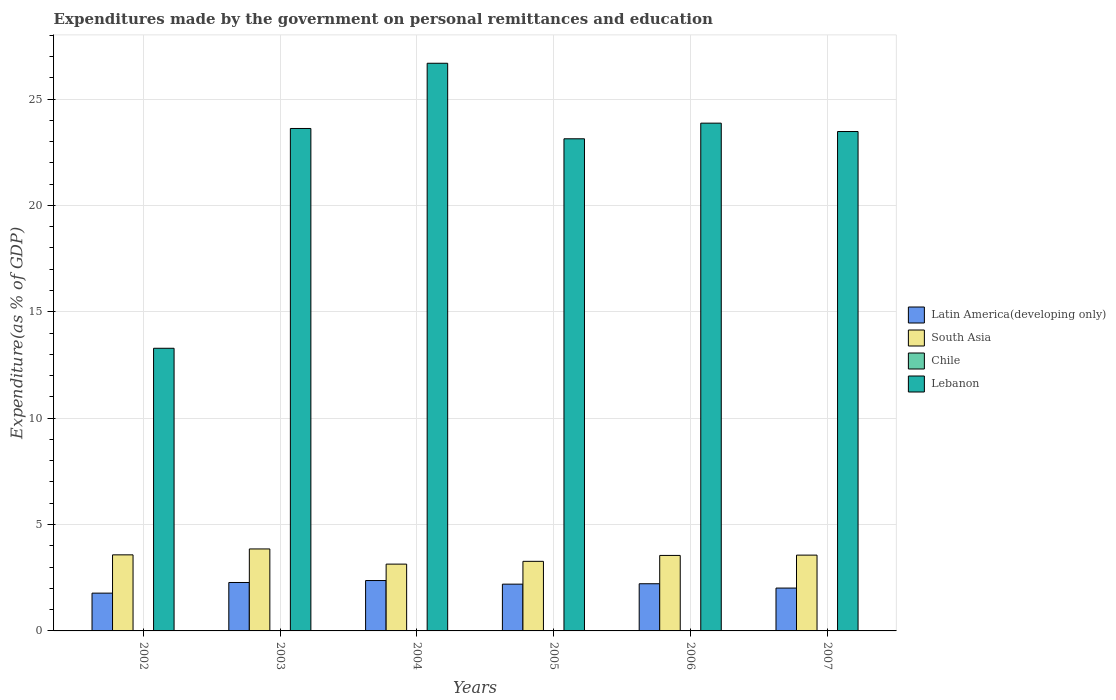How many different coloured bars are there?
Make the answer very short. 4. Are the number of bars on each tick of the X-axis equal?
Ensure brevity in your answer.  Yes. How many bars are there on the 5th tick from the right?
Offer a terse response. 4. In how many cases, is the number of bars for a given year not equal to the number of legend labels?
Provide a succinct answer. 0. What is the expenditures made by the government on personal remittances and education in Lebanon in 2004?
Your answer should be compact. 26.68. Across all years, what is the maximum expenditures made by the government on personal remittances and education in South Asia?
Your answer should be very brief. 3.85. Across all years, what is the minimum expenditures made by the government on personal remittances and education in Latin America(developing only)?
Your answer should be compact. 1.78. What is the total expenditures made by the government on personal remittances and education in Chile in the graph?
Offer a terse response. 0.06. What is the difference between the expenditures made by the government on personal remittances and education in Lebanon in 2003 and that in 2007?
Make the answer very short. 0.14. What is the difference between the expenditures made by the government on personal remittances and education in South Asia in 2006 and the expenditures made by the government on personal remittances and education in Chile in 2002?
Your answer should be very brief. 3.53. What is the average expenditures made by the government on personal remittances and education in Chile per year?
Ensure brevity in your answer.  0.01. In the year 2002, what is the difference between the expenditures made by the government on personal remittances and education in Latin America(developing only) and expenditures made by the government on personal remittances and education in South Asia?
Your answer should be very brief. -1.8. What is the ratio of the expenditures made by the government on personal remittances and education in Latin America(developing only) in 2002 to that in 2007?
Your answer should be compact. 0.88. Is the difference between the expenditures made by the government on personal remittances and education in Latin America(developing only) in 2002 and 2006 greater than the difference between the expenditures made by the government on personal remittances and education in South Asia in 2002 and 2006?
Offer a terse response. No. What is the difference between the highest and the second highest expenditures made by the government on personal remittances and education in Chile?
Make the answer very short. 0. What is the difference between the highest and the lowest expenditures made by the government on personal remittances and education in Lebanon?
Make the answer very short. 13.4. Is the sum of the expenditures made by the government on personal remittances and education in Latin America(developing only) in 2004 and 2005 greater than the maximum expenditures made by the government on personal remittances and education in Lebanon across all years?
Make the answer very short. No. Is it the case that in every year, the sum of the expenditures made by the government on personal remittances and education in South Asia and expenditures made by the government on personal remittances and education in Latin America(developing only) is greater than the sum of expenditures made by the government on personal remittances and education in Chile and expenditures made by the government on personal remittances and education in Lebanon?
Make the answer very short. No. What does the 1st bar from the right in 2005 represents?
Provide a short and direct response. Lebanon. Is it the case that in every year, the sum of the expenditures made by the government on personal remittances and education in South Asia and expenditures made by the government on personal remittances and education in Chile is greater than the expenditures made by the government on personal remittances and education in Latin America(developing only)?
Your response must be concise. Yes. Does the graph contain any zero values?
Ensure brevity in your answer.  No. Does the graph contain grids?
Provide a succinct answer. Yes. Where does the legend appear in the graph?
Your answer should be very brief. Center right. How many legend labels are there?
Provide a short and direct response. 4. How are the legend labels stacked?
Give a very brief answer. Vertical. What is the title of the graph?
Your answer should be compact. Expenditures made by the government on personal remittances and education. Does "Solomon Islands" appear as one of the legend labels in the graph?
Ensure brevity in your answer.  No. What is the label or title of the Y-axis?
Ensure brevity in your answer.  Expenditure(as % of GDP). What is the Expenditure(as % of GDP) of Latin America(developing only) in 2002?
Ensure brevity in your answer.  1.78. What is the Expenditure(as % of GDP) in South Asia in 2002?
Provide a succinct answer. 3.58. What is the Expenditure(as % of GDP) of Chile in 2002?
Offer a terse response. 0.02. What is the Expenditure(as % of GDP) in Lebanon in 2002?
Your response must be concise. 13.29. What is the Expenditure(as % of GDP) in Latin America(developing only) in 2003?
Ensure brevity in your answer.  2.28. What is the Expenditure(as % of GDP) in South Asia in 2003?
Offer a terse response. 3.85. What is the Expenditure(as % of GDP) of Chile in 2003?
Give a very brief answer. 0.02. What is the Expenditure(as % of GDP) in Lebanon in 2003?
Your answer should be compact. 23.62. What is the Expenditure(as % of GDP) of Latin America(developing only) in 2004?
Provide a short and direct response. 2.37. What is the Expenditure(as % of GDP) in South Asia in 2004?
Give a very brief answer. 3.14. What is the Expenditure(as % of GDP) of Chile in 2004?
Give a very brief answer. 0.01. What is the Expenditure(as % of GDP) in Lebanon in 2004?
Your response must be concise. 26.68. What is the Expenditure(as % of GDP) in Latin America(developing only) in 2005?
Give a very brief answer. 2.2. What is the Expenditure(as % of GDP) of South Asia in 2005?
Ensure brevity in your answer.  3.27. What is the Expenditure(as % of GDP) in Chile in 2005?
Make the answer very short. 0.01. What is the Expenditure(as % of GDP) in Lebanon in 2005?
Offer a very short reply. 23.13. What is the Expenditure(as % of GDP) of Latin America(developing only) in 2006?
Keep it short and to the point. 2.22. What is the Expenditure(as % of GDP) of South Asia in 2006?
Offer a very short reply. 3.55. What is the Expenditure(as % of GDP) of Chile in 2006?
Provide a short and direct response. 0. What is the Expenditure(as % of GDP) of Lebanon in 2006?
Your answer should be compact. 23.87. What is the Expenditure(as % of GDP) in Latin America(developing only) in 2007?
Provide a short and direct response. 2.01. What is the Expenditure(as % of GDP) of South Asia in 2007?
Ensure brevity in your answer.  3.56. What is the Expenditure(as % of GDP) in Chile in 2007?
Your answer should be compact. 0. What is the Expenditure(as % of GDP) of Lebanon in 2007?
Keep it short and to the point. 23.47. Across all years, what is the maximum Expenditure(as % of GDP) of Latin America(developing only)?
Provide a succinct answer. 2.37. Across all years, what is the maximum Expenditure(as % of GDP) in South Asia?
Offer a terse response. 3.85. Across all years, what is the maximum Expenditure(as % of GDP) in Chile?
Ensure brevity in your answer.  0.02. Across all years, what is the maximum Expenditure(as % of GDP) of Lebanon?
Ensure brevity in your answer.  26.68. Across all years, what is the minimum Expenditure(as % of GDP) of Latin America(developing only)?
Offer a very short reply. 1.78. Across all years, what is the minimum Expenditure(as % of GDP) in South Asia?
Give a very brief answer. 3.14. Across all years, what is the minimum Expenditure(as % of GDP) of Chile?
Provide a short and direct response. 0. Across all years, what is the minimum Expenditure(as % of GDP) of Lebanon?
Make the answer very short. 13.29. What is the total Expenditure(as % of GDP) in Latin America(developing only) in the graph?
Provide a short and direct response. 12.85. What is the total Expenditure(as % of GDP) in South Asia in the graph?
Provide a succinct answer. 20.95. What is the total Expenditure(as % of GDP) of Chile in the graph?
Give a very brief answer. 0.06. What is the total Expenditure(as % of GDP) of Lebanon in the graph?
Offer a terse response. 134.06. What is the difference between the Expenditure(as % of GDP) of Latin America(developing only) in 2002 and that in 2003?
Offer a very short reply. -0.5. What is the difference between the Expenditure(as % of GDP) of South Asia in 2002 and that in 2003?
Make the answer very short. -0.28. What is the difference between the Expenditure(as % of GDP) of Chile in 2002 and that in 2003?
Provide a succinct answer. 0. What is the difference between the Expenditure(as % of GDP) of Lebanon in 2002 and that in 2003?
Your answer should be compact. -10.33. What is the difference between the Expenditure(as % of GDP) of Latin America(developing only) in 2002 and that in 2004?
Ensure brevity in your answer.  -0.59. What is the difference between the Expenditure(as % of GDP) of South Asia in 2002 and that in 2004?
Your answer should be very brief. 0.44. What is the difference between the Expenditure(as % of GDP) of Chile in 2002 and that in 2004?
Provide a short and direct response. 0.01. What is the difference between the Expenditure(as % of GDP) in Lebanon in 2002 and that in 2004?
Provide a succinct answer. -13.4. What is the difference between the Expenditure(as % of GDP) in Latin America(developing only) in 2002 and that in 2005?
Make the answer very short. -0.42. What is the difference between the Expenditure(as % of GDP) of South Asia in 2002 and that in 2005?
Give a very brief answer. 0.3. What is the difference between the Expenditure(as % of GDP) of Chile in 2002 and that in 2005?
Your answer should be compact. 0.01. What is the difference between the Expenditure(as % of GDP) of Lebanon in 2002 and that in 2005?
Offer a terse response. -9.85. What is the difference between the Expenditure(as % of GDP) in Latin America(developing only) in 2002 and that in 2006?
Offer a very short reply. -0.44. What is the difference between the Expenditure(as % of GDP) in South Asia in 2002 and that in 2006?
Provide a short and direct response. 0.03. What is the difference between the Expenditure(as % of GDP) of Chile in 2002 and that in 2006?
Make the answer very short. 0.02. What is the difference between the Expenditure(as % of GDP) in Lebanon in 2002 and that in 2006?
Provide a short and direct response. -10.58. What is the difference between the Expenditure(as % of GDP) of Latin America(developing only) in 2002 and that in 2007?
Offer a very short reply. -0.24. What is the difference between the Expenditure(as % of GDP) in South Asia in 2002 and that in 2007?
Make the answer very short. 0.01. What is the difference between the Expenditure(as % of GDP) of Chile in 2002 and that in 2007?
Ensure brevity in your answer.  0.02. What is the difference between the Expenditure(as % of GDP) of Lebanon in 2002 and that in 2007?
Ensure brevity in your answer.  -10.19. What is the difference between the Expenditure(as % of GDP) of Latin America(developing only) in 2003 and that in 2004?
Give a very brief answer. -0.09. What is the difference between the Expenditure(as % of GDP) in South Asia in 2003 and that in 2004?
Ensure brevity in your answer.  0.71. What is the difference between the Expenditure(as % of GDP) of Chile in 2003 and that in 2004?
Your response must be concise. 0. What is the difference between the Expenditure(as % of GDP) of Lebanon in 2003 and that in 2004?
Provide a short and direct response. -3.07. What is the difference between the Expenditure(as % of GDP) in Latin America(developing only) in 2003 and that in 2005?
Make the answer very short. 0.08. What is the difference between the Expenditure(as % of GDP) in South Asia in 2003 and that in 2005?
Your response must be concise. 0.58. What is the difference between the Expenditure(as % of GDP) of Chile in 2003 and that in 2005?
Provide a short and direct response. 0. What is the difference between the Expenditure(as % of GDP) in Lebanon in 2003 and that in 2005?
Provide a succinct answer. 0.48. What is the difference between the Expenditure(as % of GDP) in Latin America(developing only) in 2003 and that in 2006?
Ensure brevity in your answer.  0.06. What is the difference between the Expenditure(as % of GDP) of South Asia in 2003 and that in 2006?
Your answer should be very brief. 0.3. What is the difference between the Expenditure(as % of GDP) of Chile in 2003 and that in 2006?
Keep it short and to the point. 0.01. What is the difference between the Expenditure(as % of GDP) of Lebanon in 2003 and that in 2006?
Ensure brevity in your answer.  -0.25. What is the difference between the Expenditure(as % of GDP) of Latin America(developing only) in 2003 and that in 2007?
Your answer should be compact. 0.26. What is the difference between the Expenditure(as % of GDP) of South Asia in 2003 and that in 2007?
Ensure brevity in your answer.  0.29. What is the difference between the Expenditure(as % of GDP) in Chile in 2003 and that in 2007?
Your answer should be very brief. 0.01. What is the difference between the Expenditure(as % of GDP) in Lebanon in 2003 and that in 2007?
Give a very brief answer. 0.14. What is the difference between the Expenditure(as % of GDP) in Latin America(developing only) in 2004 and that in 2005?
Keep it short and to the point. 0.17. What is the difference between the Expenditure(as % of GDP) in South Asia in 2004 and that in 2005?
Keep it short and to the point. -0.13. What is the difference between the Expenditure(as % of GDP) of Chile in 2004 and that in 2005?
Your response must be concise. 0. What is the difference between the Expenditure(as % of GDP) in Lebanon in 2004 and that in 2005?
Your answer should be very brief. 3.55. What is the difference between the Expenditure(as % of GDP) of Latin America(developing only) in 2004 and that in 2006?
Provide a succinct answer. 0.15. What is the difference between the Expenditure(as % of GDP) in South Asia in 2004 and that in 2006?
Provide a succinct answer. -0.41. What is the difference between the Expenditure(as % of GDP) in Chile in 2004 and that in 2006?
Offer a very short reply. 0.01. What is the difference between the Expenditure(as % of GDP) in Lebanon in 2004 and that in 2006?
Make the answer very short. 2.82. What is the difference between the Expenditure(as % of GDP) in Latin America(developing only) in 2004 and that in 2007?
Offer a very short reply. 0.35. What is the difference between the Expenditure(as % of GDP) in South Asia in 2004 and that in 2007?
Keep it short and to the point. -0.42. What is the difference between the Expenditure(as % of GDP) in Chile in 2004 and that in 2007?
Provide a short and direct response. 0.01. What is the difference between the Expenditure(as % of GDP) of Lebanon in 2004 and that in 2007?
Provide a succinct answer. 3.21. What is the difference between the Expenditure(as % of GDP) in Latin America(developing only) in 2005 and that in 2006?
Offer a terse response. -0.02. What is the difference between the Expenditure(as % of GDP) of South Asia in 2005 and that in 2006?
Give a very brief answer. -0.28. What is the difference between the Expenditure(as % of GDP) of Chile in 2005 and that in 2006?
Give a very brief answer. 0.01. What is the difference between the Expenditure(as % of GDP) of Lebanon in 2005 and that in 2006?
Provide a short and direct response. -0.74. What is the difference between the Expenditure(as % of GDP) in Latin America(developing only) in 2005 and that in 2007?
Provide a succinct answer. 0.18. What is the difference between the Expenditure(as % of GDP) in South Asia in 2005 and that in 2007?
Your answer should be compact. -0.29. What is the difference between the Expenditure(as % of GDP) of Chile in 2005 and that in 2007?
Provide a succinct answer. 0.01. What is the difference between the Expenditure(as % of GDP) of Lebanon in 2005 and that in 2007?
Offer a very short reply. -0.34. What is the difference between the Expenditure(as % of GDP) in Latin America(developing only) in 2006 and that in 2007?
Offer a terse response. 0.2. What is the difference between the Expenditure(as % of GDP) in South Asia in 2006 and that in 2007?
Your answer should be very brief. -0.01. What is the difference between the Expenditure(as % of GDP) in Chile in 2006 and that in 2007?
Ensure brevity in your answer.  0. What is the difference between the Expenditure(as % of GDP) of Lebanon in 2006 and that in 2007?
Offer a very short reply. 0.39. What is the difference between the Expenditure(as % of GDP) of Latin America(developing only) in 2002 and the Expenditure(as % of GDP) of South Asia in 2003?
Keep it short and to the point. -2.08. What is the difference between the Expenditure(as % of GDP) of Latin America(developing only) in 2002 and the Expenditure(as % of GDP) of Chile in 2003?
Give a very brief answer. 1.76. What is the difference between the Expenditure(as % of GDP) of Latin America(developing only) in 2002 and the Expenditure(as % of GDP) of Lebanon in 2003?
Keep it short and to the point. -21.84. What is the difference between the Expenditure(as % of GDP) of South Asia in 2002 and the Expenditure(as % of GDP) of Chile in 2003?
Offer a very short reply. 3.56. What is the difference between the Expenditure(as % of GDP) in South Asia in 2002 and the Expenditure(as % of GDP) in Lebanon in 2003?
Make the answer very short. -20.04. What is the difference between the Expenditure(as % of GDP) of Chile in 2002 and the Expenditure(as % of GDP) of Lebanon in 2003?
Offer a very short reply. -23.6. What is the difference between the Expenditure(as % of GDP) in Latin America(developing only) in 2002 and the Expenditure(as % of GDP) in South Asia in 2004?
Your response must be concise. -1.36. What is the difference between the Expenditure(as % of GDP) in Latin America(developing only) in 2002 and the Expenditure(as % of GDP) in Chile in 2004?
Give a very brief answer. 1.76. What is the difference between the Expenditure(as % of GDP) of Latin America(developing only) in 2002 and the Expenditure(as % of GDP) of Lebanon in 2004?
Offer a terse response. -24.91. What is the difference between the Expenditure(as % of GDP) of South Asia in 2002 and the Expenditure(as % of GDP) of Chile in 2004?
Your response must be concise. 3.56. What is the difference between the Expenditure(as % of GDP) of South Asia in 2002 and the Expenditure(as % of GDP) of Lebanon in 2004?
Make the answer very short. -23.11. What is the difference between the Expenditure(as % of GDP) of Chile in 2002 and the Expenditure(as % of GDP) of Lebanon in 2004?
Provide a short and direct response. -26.67. What is the difference between the Expenditure(as % of GDP) in Latin America(developing only) in 2002 and the Expenditure(as % of GDP) in South Asia in 2005?
Provide a succinct answer. -1.49. What is the difference between the Expenditure(as % of GDP) of Latin America(developing only) in 2002 and the Expenditure(as % of GDP) of Chile in 2005?
Your answer should be compact. 1.77. What is the difference between the Expenditure(as % of GDP) of Latin America(developing only) in 2002 and the Expenditure(as % of GDP) of Lebanon in 2005?
Provide a short and direct response. -21.36. What is the difference between the Expenditure(as % of GDP) in South Asia in 2002 and the Expenditure(as % of GDP) in Chile in 2005?
Provide a short and direct response. 3.57. What is the difference between the Expenditure(as % of GDP) in South Asia in 2002 and the Expenditure(as % of GDP) in Lebanon in 2005?
Provide a short and direct response. -19.56. What is the difference between the Expenditure(as % of GDP) in Chile in 2002 and the Expenditure(as % of GDP) in Lebanon in 2005?
Ensure brevity in your answer.  -23.11. What is the difference between the Expenditure(as % of GDP) of Latin America(developing only) in 2002 and the Expenditure(as % of GDP) of South Asia in 2006?
Provide a short and direct response. -1.77. What is the difference between the Expenditure(as % of GDP) of Latin America(developing only) in 2002 and the Expenditure(as % of GDP) of Chile in 2006?
Offer a very short reply. 1.77. What is the difference between the Expenditure(as % of GDP) of Latin America(developing only) in 2002 and the Expenditure(as % of GDP) of Lebanon in 2006?
Your answer should be very brief. -22.09. What is the difference between the Expenditure(as % of GDP) in South Asia in 2002 and the Expenditure(as % of GDP) in Chile in 2006?
Keep it short and to the point. 3.57. What is the difference between the Expenditure(as % of GDP) of South Asia in 2002 and the Expenditure(as % of GDP) of Lebanon in 2006?
Ensure brevity in your answer.  -20.29. What is the difference between the Expenditure(as % of GDP) in Chile in 2002 and the Expenditure(as % of GDP) in Lebanon in 2006?
Your response must be concise. -23.85. What is the difference between the Expenditure(as % of GDP) of Latin America(developing only) in 2002 and the Expenditure(as % of GDP) of South Asia in 2007?
Offer a terse response. -1.79. What is the difference between the Expenditure(as % of GDP) in Latin America(developing only) in 2002 and the Expenditure(as % of GDP) in Chile in 2007?
Provide a succinct answer. 1.77. What is the difference between the Expenditure(as % of GDP) of Latin America(developing only) in 2002 and the Expenditure(as % of GDP) of Lebanon in 2007?
Your response must be concise. -21.7. What is the difference between the Expenditure(as % of GDP) in South Asia in 2002 and the Expenditure(as % of GDP) in Chile in 2007?
Your response must be concise. 3.57. What is the difference between the Expenditure(as % of GDP) in South Asia in 2002 and the Expenditure(as % of GDP) in Lebanon in 2007?
Make the answer very short. -19.9. What is the difference between the Expenditure(as % of GDP) in Chile in 2002 and the Expenditure(as % of GDP) in Lebanon in 2007?
Provide a succinct answer. -23.46. What is the difference between the Expenditure(as % of GDP) in Latin America(developing only) in 2003 and the Expenditure(as % of GDP) in South Asia in 2004?
Keep it short and to the point. -0.86. What is the difference between the Expenditure(as % of GDP) of Latin America(developing only) in 2003 and the Expenditure(as % of GDP) of Chile in 2004?
Provide a short and direct response. 2.27. What is the difference between the Expenditure(as % of GDP) in Latin America(developing only) in 2003 and the Expenditure(as % of GDP) in Lebanon in 2004?
Offer a very short reply. -24.41. What is the difference between the Expenditure(as % of GDP) of South Asia in 2003 and the Expenditure(as % of GDP) of Chile in 2004?
Ensure brevity in your answer.  3.84. What is the difference between the Expenditure(as % of GDP) of South Asia in 2003 and the Expenditure(as % of GDP) of Lebanon in 2004?
Give a very brief answer. -22.83. What is the difference between the Expenditure(as % of GDP) of Chile in 2003 and the Expenditure(as % of GDP) of Lebanon in 2004?
Make the answer very short. -26.67. What is the difference between the Expenditure(as % of GDP) of Latin America(developing only) in 2003 and the Expenditure(as % of GDP) of South Asia in 2005?
Offer a very short reply. -0.99. What is the difference between the Expenditure(as % of GDP) in Latin America(developing only) in 2003 and the Expenditure(as % of GDP) in Chile in 2005?
Your answer should be very brief. 2.27. What is the difference between the Expenditure(as % of GDP) in Latin America(developing only) in 2003 and the Expenditure(as % of GDP) in Lebanon in 2005?
Your answer should be compact. -20.86. What is the difference between the Expenditure(as % of GDP) in South Asia in 2003 and the Expenditure(as % of GDP) in Chile in 2005?
Your response must be concise. 3.84. What is the difference between the Expenditure(as % of GDP) of South Asia in 2003 and the Expenditure(as % of GDP) of Lebanon in 2005?
Your answer should be very brief. -19.28. What is the difference between the Expenditure(as % of GDP) of Chile in 2003 and the Expenditure(as % of GDP) of Lebanon in 2005?
Your answer should be very brief. -23.12. What is the difference between the Expenditure(as % of GDP) of Latin America(developing only) in 2003 and the Expenditure(as % of GDP) of South Asia in 2006?
Offer a very short reply. -1.27. What is the difference between the Expenditure(as % of GDP) of Latin America(developing only) in 2003 and the Expenditure(as % of GDP) of Chile in 2006?
Your answer should be very brief. 2.27. What is the difference between the Expenditure(as % of GDP) in Latin America(developing only) in 2003 and the Expenditure(as % of GDP) in Lebanon in 2006?
Keep it short and to the point. -21.59. What is the difference between the Expenditure(as % of GDP) of South Asia in 2003 and the Expenditure(as % of GDP) of Chile in 2006?
Provide a short and direct response. 3.85. What is the difference between the Expenditure(as % of GDP) of South Asia in 2003 and the Expenditure(as % of GDP) of Lebanon in 2006?
Ensure brevity in your answer.  -20.01. What is the difference between the Expenditure(as % of GDP) of Chile in 2003 and the Expenditure(as % of GDP) of Lebanon in 2006?
Your response must be concise. -23.85. What is the difference between the Expenditure(as % of GDP) of Latin America(developing only) in 2003 and the Expenditure(as % of GDP) of South Asia in 2007?
Keep it short and to the point. -1.29. What is the difference between the Expenditure(as % of GDP) in Latin America(developing only) in 2003 and the Expenditure(as % of GDP) in Chile in 2007?
Your answer should be compact. 2.27. What is the difference between the Expenditure(as % of GDP) of Latin America(developing only) in 2003 and the Expenditure(as % of GDP) of Lebanon in 2007?
Ensure brevity in your answer.  -21.2. What is the difference between the Expenditure(as % of GDP) of South Asia in 2003 and the Expenditure(as % of GDP) of Chile in 2007?
Offer a very short reply. 3.85. What is the difference between the Expenditure(as % of GDP) in South Asia in 2003 and the Expenditure(as % of GDP) in Lebanon in 2007?
Ensure brevity in your answer.  -19.62. What is the difference between the Expenditure(as % of GDP) in Chile in 2003 and the Expenditure(as % of GDP) in Lebanon in 2007?
Your answer should be very brief. -23.46. What is the difference between the Expenditure(as % of GDP) of Latin America(developing only) in 2004 and the Expenditure(as % of GDP) of South Asia in 2005?
Your response must be concise. -0.9. What is the difference between the Expenditure(as % of GDP) of Latin America(developing only) in 2004 and the Expenditure(as % of GDP) of Chile in 2005?
Your answer should be very brief. 2.36. What is the difference between the Expenditure(as % of GDP) in Latin America(developing only) in 2004 and the Expenditure(as % of GDP) in Lebanon in 2005?
Provide a succinct answer. -20.76. What is the difference between the Expenditure(as % of GDP) of South Asia in 2004 and the Expenditure(as % of GDP) of Chile in 2005?
Provide a short and direct response. 3.13. What is the difference between the Expenditure(as % of GDP) in South Asia in 2004 and the Expenditure(as % of GDP) in Lebanon in 2005?
Provide a short and direct response. -19.99. What is the difference between the Expenditure(as % of GDP) of Chile in 2004 and the Expenditure(as % of GDP) of Lebanon in 2005?
Your response must be concise. -23.12. What is the difference between the Expenditure(as % of GDP) in Latin America(developing only) in 2004 and the Expenditure(as % of GDP) in South Asia in 2006?
Offer a very short reply. -1.18. What is the difference between the Expenditure(as % of GDP) in Latin America(developing only) in 2004 and the Expenditure(as % of GDP) in Chile in 2006?
Provide a short and direct response. 2.37. What is the difference between the Expenditure(as % of GDP) in Latin America(developing only) in 2004 and the Expenditure(as % of GDP) in Lebanon in 2006?
Ensure brevity in your answer.  -21.5. What is the difference between the Expenditure(as % of GDP) in South Asia in 2004 and the Expenditure(as % of GDP) in Chile in 2006?
Your answer should be very brief. 3.14. What is the difference between the Expenditure(as % of GDP) of South Asia in 2004 and the Expenditure(as % of GDP) of Lebanon in 2006?
Give a very brief answer. -20.73. What is the difference between the Expenditure(as % of GDP) in Chile in 2004 and the Expenditure(as % of GDP) in Lebanon in 2006?
Provide a succinct answer. -23.86. What is the difference between the Expenditure(as % of GDP) of Latin America(developing only) in 2004 and the Expenditure(as % of GDP) of South Asia in 2007?
Offer a very short reply. -1.19. What is the difference between the Expenditure(as % of GDP) of Latin America(developing only) in 2004 and the Expenditure(as % of GDP) of Chile in 2007?
Offer a terse response. 2.37. What is the difference between the Expenditure(as % of GDP) of Latin America(developing only) in 2004 and the Expenditure(as % of GDP) of Lebanon in 2007?
Your answer should be very brief. -21.11. What is the difference between the Expenditure(as % of GDP) of South Asia in 2004 and the Expenditure(as % of GDP) of Chile in 2007?
Ensure brevity in your answer.  3.14. What is the difference between the Expenditure(as % of GDP) of South Asia in 2004 and the Expenditure(as % of GDP) of Lebanon in 2007?
Provide a short and direct response. -20.33. What is the difference between the Expenditure(as % of GDP) in Chile in 2004 and the Expenditure(as % of GDP) in Lebanon in 2007?
Provide a succinct answer. -23.46. What is the difference between the Expenditure(as % of GDP) of Latin America(developing only) in 2005 and the Expenditure(as % of GDP) of South Asia in 2006?
Provide a succinct answer. -1.35. What is the difference between the Expenditure(as % of GDP) in Latin America(developing only) in 2005 and the Expenditure(as % of GDP) in Chile in 2006?
Your answer should be compact. 2.2. What is the difference between the Expenditure(as % of GDP) of Latin America(developing only) in 2005 and the Expenditure(as % of GDP) of Lebanon in 2006?
Your answer should be very brief. -21.67. What is the difference between the Expenditure(as % of GDP) in South Asia in 2005 and the Expenditure(as % of GDP) in Chile in 2006?
Your response must be concise. 3.27. What is the difference between the Expenditure(as % of GDP) in South Asia in 2005 and the Expenditure(as % of GDP) in Lebanon in 2006?
Offer a terse response. -20.6. What is the difference between the Expenditure(as % of GDP) in Chile in 2005 and the Expenditure(as % of GDP) in Lebanon in 2006?
Your response must be concise. -23.86. What is the difference between the Expenditure(as % of GDP) in Latin America(developing only) in 2005 and the Expenditure(as % of GDP) in South Asia in 2007?
Offer a very short reply. -1.36. What is the difference between the Expenditure(as % of GDP) in Latin America(developing only) in 2005 and the Expenditure(as % of GDP) in Chile in 2007?
Provide a succinct answer. 2.2. What is the difference between the Expenditure(as % of GDP) in Latin America(developing only) in 2005 and the Expenditure(as % of GDP) in Lebanon in 2007?
Provide a short and direct response. -21.28. What is the difference between the Expenditure(as % of GDP) in South Asia in 2005 and the Expenditure(as % of GDP) in Chile in 2007?
Your response must be concise. 3.27. What is the difference between the Expenditure(as % of GDP) in South Asia in 2005 and the Expenditure(as % of GDP) in Lebanon in 2007?
Offer a very short reply. -20.2. What is the difference between the Expenditure(as % of GDP) of Chile in 2005 and the Expenditure(as % of GDP) of Lebanon in 2007?
Offer a very short reply. -23.46. What is the difference between the Expenditure(as % of GDP) of Latin America(developing only) in 2006 and the Expenditure(as % of GDP) of South Asia in 2007?
Make the answer very short. -1.35. What is the difference between the Expenditure(as % of GDP) in Latin America(developing only) in 2006 and the Expenditure(as % of GDP) in Chile in 2007?
Ensure brevity in your answer.  2.22. What is the difference between the Expenditure(as % of GDP) of Latin America(developing only) in 2006 and the Expenditure(as % of GDP) of Lebanon in 2007?
Offer a terse response. -21.26. What is the difference between the Expenditure(as % of GDP) of South Asia in 2006 and the Expenditure(as % of GDP) of Chile in 2007?
Offer a terse response. 3.55. What is the difference between the Expenditure(as % of GDP) of South Asia in 2006 and the Expenditure(as % of GDP) of Lebanon in 2007?
Keep it short and to the point. -19.93. What is the difference between the Expenditure(as % of GDP) in Chile in 2006 and the Expenditure(as % of GDP) in Lebanon in 2007?
Ensure brevity in your answer.  -23.47. What is the average Expenditure(as % of GDP) of Latin America(developing only) per year?
Your answer should be very brief. 2.14. What is the average Expenditure(as % of GDP) of South Asia per year?
Offer a very short reply. 3.49. What is the average Expenditure(as % of GDP) in Chile per year?
Make the answer very short. 0.01. What is the average Expenditure(as % of GDP) of Lebanon per year?
Your answer should be very brief. 22.34. In the year 2002, what is the difference between the Expenditure(as % of GDP) of Latin America(developing only) and Expenditure(as % of GDP) of South Asia?
Keep it short and to the point. -1.8. In the year 2002, what is the difference between the Expenditure(as % of GDP) in Latin America(developing only) and Expenditure(as % of GDP) in Chile?
Your answer should be very brief. 1.76. In the year 2002, what is the difference between the Expenditure(as % of GDP) in Latin America(developing only) and Expenditure(as % of GDP) in Lebanon?
Offer a terse response. -11.51. In the year 2002, what is the difference between the Expenditure(as % of GDP) of South Asia and Expenditure(as % of GDP) of Chile?
Keep it short and to the point. 3.56. In the year 2002, what is the difference between the Expenditure(as % of GDP) of South Asia and Expenditure(as % of GDP) of Lebanon?
Provide a succinct answer. -9.71. In the year 2002, what is the difference between the Expenditure(as % of GDP) in Chile and Expenditure(as % of GDP) in Lebanon?
Make the answer very short. -13.27. In the year 2003, what is the difference between the Expenditure(as % of GDP) of Latin America(developing only) and Expenditure(as % of GDP) of South Asia?
Offer a terse response. -1.58. In the year 2003, what is the difference between the Expenditure(as % of GDP) of Latin America(developing only) and Expenditure(as % of GDP) of Chile?
Offer a terse response. 2.26. In the year 2003, what is the difference between the Expenditure(as % of GDP) in Latin America(developing only) and Expenditure(as % of GDP) in Lebanon?
Offer a very short reply. -21.34. In the year 2003, what is the difference between the Expenditure(as % of GDP) of South Asia and Expenditure(as % of GDP) of Chile?
Provide a short and direct response. 3.84. In the year 2003, what is the difference between the Expenditure(as % of GDP) in South Asia and Expenditure(as % of GDP) in Lebanon?
Your answer should be compact. -19.76. In the year 2003, what is the difference between the Expenditure(as % of GDP) of Chile and Expenditure(as % of GDP) of Lebanon?
Your response must be concise. -23.6. In the year 2004, what is the difference between the Expenditure(as % of GDP) in Latin America(developing only) and Expenditure(as % of GDP) in South Asia?
Your response must be concise. -0.77. In the year 2004, what is the difference between the Expenditure(as % of GDP) of Latin America(developing only) and Expenditure(as % of GDP) of Chile?
Your answer should be very brief. 2.36. In the year 2004, what is the difference between the Expenditure(as % of GDP) of Latin America(developing only) and Expenditure(as % of GDP) of Lebanon?
Your response must be concise. -24.31. In the year 2004, what is the difference between the Expenditure(as % of GDP) of South Asia and Expenditure(as % of GDP) of Chile?
Provide a short and direct response. 3.13. In the year 2004, what is the difference between the Expenditure(as % of GDP) of South Asia and Expenditure(as % of GDP) of Lebanon?
Provide a succinct answer. -23.54. In the year 2004, what is the difference between the Expenditure(as % of GDP) in Chile and Expenditure(as % of GDP) in Lebanon?
Provide a short and direct response. -26.67. In the year 2005, what is the difference between the Expenditure(as % of GDP) in Latin America(developing only) and Expenditure(as % of GDP) in South Asia?
Provide a short and direct response. -1.07. In the year 2005, what is the difference between the Expenditure(as % of GDP) of Latin America(developing only) and Expenditure(as % of GDP) of Chile?
Keep it short and to the point. 2.19. In the year 2005, what is the difference between the Expenditure(as % of GDP) of Latin America(developing only) and Expenditure(as % of GDP) of Lebanon?
Provide a succinct answer. -20.93. In the year 2005, what is the difference between the Expenditure(as % of GDP) in South Asia and Expenditure(as % of GDP) in Chile?
Your answer should be compact. 3.26. In the year 2005, what is the difference between the Expenditure(as % of GDP) in South Asia and Expenditure(as % of GDP) in Lebanon?
Your answer should be compact. -19.86. In the year 2005, what is the difference between the Expenditure(as % of GDP) of Chile and Expenditure(as % of GDP) of Lebanon?
Ensure brevity in your answer.  -23.12. In the year 2006, what is the difference between the Expenditure(as % of GDP) in Latin America(developing only) and Expenditure(as % of GDP) in South Asia?
Give a very brief answer. -1.33. In the year 2006, what is the difference between the Expenditure(as % of GDP) of Latin America(developing only) and Expenditure(as % of GDP) of Chile?
Provide a short and direct response. 2.22. In the year 2006, what is the difference between the Expenditure(as % of GDP) of Latin America(developing only) and Expenditure(as % of GDP) of Lebanon?
Make the answer very short. -21.65. In the year 2006, what is the difference between the Expenditure(as % of GDP) in South Asia and Expenditure(as % of GDP) in Chile?
Your answer should be very brief. 3.55. In the year 2006, what is the difference between the Expenditure(as % of GDP) in South Asia and Expenditure(as % of GDP) in Lebanon?
Your answer should be compact. -20.32. In the year 2006, what is the difference between the Expenditure(as % of GDP) of Chile and Expenditure(as % of GDP) of Lebanon?
Your answer should be very brief. -23.87. In the year 2007, what is the difference between the Expenditure(as % of GDP) of Latin America(developing only) and Expenditure(as % of GDP) of South Asia?
Your answer should be compact. -1.55. In the year 2007, what is the difference between the Expenditure(as % of GDP) of Latin America(developing only) and Expenditure(as % of GDP) of Chile?
Offer a very short reply. 2.01. In the year 2007, what is the difference between the Expenditure(as % of GDP) in Latin America(developing only) and Expenditure(as % of GDP) in Lebanon?
Give a very brief answer. -21.46. In the year 2007, what is the difference between the Expenditure(as % of GDP) in South Asia and Expenditure(as % of GDP) in Chile?
Keep it short and to the point. 3.56. In the year 2007, what is the difference between the Expenditure(as % of GDP) of South Asia and Expenditure(as % of GDP) of Lebanon?
Your answer should be compact. -19.91. In the year 2007, what is the difference between the Expenditure(as % of GDP) of Chile and Expenditure(as % of GDP) of Lebanon?
Keep it short and to the point. -23.47. What is the ratio of the Expenditure(as % of GDP) of Latin America(developing only) in 2002 to that in 2003?
Keep it short and to the point. 0.78. What is the ratio of the Expenditure(as % of GDP) in South Asia in 2002 to that in 2003?
Give a very brief answer. 0.93. What is the ratio of the Expenditure(as % of GDP) of Chile in 2002 to that in 2003?
Provide a succinct answer. 1.15. What is the ratio of the Expenditure(as % of GDP) of Lebanon in 2002 to that in 2003?
Your response must be concise. 0.56. What is the ratio of the Expenditure(as % of GDP) in South Asia in 2002 to that in 2004?
Your answer should be very brief. 1.14. What is the ratio of the Expenditure(as % of GDP) of Chile in 2002 to that in 2004?
Your answer should be very brief. 1.52. What is the ratio of the Expenditure(as % of GDP) in Lebanon in 2002 to that in 2004?
Offer a terse response. 0.5. What is the ratio of the Expenditure(as % of GDP) in Latin America(developing only) in 2002 to that in 2005?
Provide a short and direct response. 0.81. What is the ratio of the Expenditure(as % of GDP) of South Asia in 2002 to that in 2005?
Offer a terse response. 1.09. What is the ratio of the Expenditure(as % of GDP) of Chile in 2002 to that in 2005?
Your answer should be compact. 1.67. What is the ratio of the Expenditure(as % of GDP) in Lebanon in 2002 to that in 2005?
Give a very brief answer. 0.57. What is the ratio of the Expenditure(as % of GDP) of Latin America(developing only) in 2002 to that in 2006?
Ensure brevity in your answer.  0.8. What is the ratio of the Expenditure(as % of GDP) of South Asia in 2002 to that in 2006?
Provide a succinct answer. 1.01. What is the ratio of the Expenditure(as % of GDP) of Chile in 2002 to that in 2006?
Make the answer very short. 10.81. What is the ratio of the Expenditure(as % of GDP) in Lebanon in 2002 to that in 2006?
Offer a very short reply. 0.56. What is the ratio of the Expenditure(as % of GDP) in Latin America(developing only) in 2002 to that in 2007?
Provide a short and direct response. 0.88. What is the ratio of the Expenditure(as % of GDP) in South Asia in 2002 to that in 2007?
Your answer should be very brief. 1. What is the ratio of the Expenditure(as % of GDP) in Chile in 2002 to that in 2007?
Offer a terse response. 12.09. What is the ratio of the Expenditure(as % of GDP) in Lebanon in 2002 to that in 2007?
Offer a very short reply. 0.57. What is the ratio of the Expenditure(as % of GDP) in Latin America(developing only) in 2003 to that in 2004?
Keep it short and to the point. 0.96. What is the ratio of the Expenditure(as % of GDP) of South Asia in 2003 to that in 2004?
Offer a terse response. 1.23. What is the ratio of the Expenditure(as % of GDP) in Chile in 2003 to that in 2004?
Your answer should be very brief. 1.32. What is the ratio of the Expenditure(as % of GDP) in Lebanon in 2003 to that in 2004?
Your response must be concise. 0.89. What is the ratio of the Expenditure(as % of GDP) of Latin America(developing only) in 2003 to that in 2005?
Your answer should be very brief. 1.04. What is the ratio of the Expenditure(as % of GDP) of South Asia in 2003 to that in 2005?
Your response must be concise. 1.18. What is the ratio of the Expenditure(as % of GDP) of Chile in 2003 to that in 2005?
Give a very brief answer. 1.45. What is the ratio of the Expenditure(as % of GDP) of Latin America(developing only) in 2003 to that in 2006?
Provide a succinct answer. 1.03. What is the ratio of the Expenditure(as % of GDP) of South Asia in 2003 to that in 2006?
Offer a very short reply. 1.09. What is the ratio of the Expenditure(as % of GDP) in Chile in 2003 to that in 2006?
Your answer should be compact. 9.38. What is the ratio of the Expenditure(as % of GDP) of Lebanon in 2003 to that in 2006?
Offer a very short reply. 0.99. What is the ratio of the Expenditure(as % of GDP) of Latin America(developing only) in 2003 to that in 2007?
Give a very brief answer. 1.13. What is the ratio of the Expenditure(as % of GDP) in South Asia in 2003 to that in 2007?
Your response must be concise. 1.08. What is the ratio of the Expenditure(as % of GDP) in Chile in 2003 to that in 2007?
Your answer should be compact. 10.5. What is the ratio of the Expenditure(as % of GDP) in Lebanon in 2003 to that in 2007?
Your answer should be compact. 1.01. What is the ratio of the Expenditure(as % of GDP) in Latin America(developing only) in 2004 to that in 2005?
Give a very brief answer. 1.08. What is the ratio of the Expenditure(as % of GDP) of South Asia in 2004 to that in 2005?
Provide a short and direct response. 0.96. What is the ratio of the Expenditure(as % of GDP) in Chile in 2004 to that in 2005?
Provide a short and direct response. 1.1. What is the ratio of the Expenditure(as % of GDP) of Lebanon in 2004 to that in 2005?
Offer a very short reply. 1.15. What is the ratio of the Expenditure(as % of GDP) of Latin America(developing only) in 2004 to that in 2006?
Keep it short and to the point. 1.07. What is the ratio of the Expenditure(as % of GDP) in South Asia in 2004 to that in 2006?
Offer a terse response. 0.88. What is the ratio of the Expenditure(as % of GDP) in Chile in 2004 to that in 2006?
Keep it short and to the point. 7.13. What is the ratio of the Expenditure(as % of GDP) of Lebanon in 2004 to that in 2006?
Your answer should be very brief. 1.12. What is the ratio of the Expenditure(as % of GDP) in Latin America(developing only) in 2004 to that in 2007?
Offer a very short reply. 1.18. What is the ratio of the Expenditure(as % of GDP) in South Asia in 2004 to that in 2007?
Your response must be concise. 0.88. What is the ratio of the Expenditure(as % of GDP) of Chile in 2004 to that in 2007?
Make the answer very short. 7.98. What is the ratio of the Expenditure(as % of GDP) of Lebanon in 2004 to that in 2007?
Your response must be concise. 1.14. What is the ratio of the Expenditure(as % of GDP) of Latin America(developing only) in 2005 to that in 2006?
Your answer should be very brief. 0.99. What is the ratio of the Expenditure(as % of GDP) in South Asia in 2005 to that in 2006?
Your answer should be very brief. 0.92. What is the ratio of the Expenditure(as % of GDP) of Chile in 2005 to that in 2006?
Your answer should be compact. 6.47. What is the ratio of the Expenditure(as % of GDP) in Lebanon in 2005 to that in 2006?
Keep it short and to the point. 0.97. What is the ratio of the Expenditure(as % of GDP) of Latin America(developing only) in 2005 to that in 2007?
Provide a short and direct response. 1.09. What is the ratio of the Expenditure(as % of GDP) of South Asia in 2005 to that in 2007?
Provide a short and direct response. 0.92. What is the ratio of the Expenditure(as % of GDP) in Chile in 2005 to that in 2007?
Your answer should be very brief. 7.23. What is the ratio of the Expenditure(as % of GDP) of Lebanon in 2005 to that in 2007?
Provide a short and direct response. 0.99. What is the ratio of the Expenditure(as % of GDP) in Latin America(developing only) in 2006 to that in 2007?
Ensure brevity in your answer.  1.1. What is the ratio of the Expenditure(as % of GDP) in Chile in 2006 to that in 2007?
Your answer should be very brief. 1.12. What is the ratio of the Expenditure(as % of GDP) of Lebanon in 2006 to that in 2007?
Ensure brevity in your answer.  1.02. What is the difference between the highest and the second highest Expenditure(as % of GDP) of Latin America(developing only)?
Give a very brief answer. 0.09. What is the difference between the highest and the second highest Expenditure(as % of GDP) of South Asia?
Ensure brevity in your answer.  0.28. What is the difference between the highest and the second highest Expenditure(as % of GDP) in Chile?
Provide a succinct answer. 0. What is the difference between the highest and the second highest Expenditure(as % of GDP) of Lebanon?
Your response must be concise. 2.82. What is the difference between the highest and the lowest Expenditure(as % of GDP) of Latin America(developing only)?
Give a very brief answer. 0.59. What is the difference between the highest and the lowest Expenditure(as % of GDP) in South Asia?
Ensure brevity in your answer.  0.71. What is the difference between the highest and the lowest Expenditure(as % of GDP) of Chile?
Your response must be concise. 0.02. What is the difference between the highest and the lowest Expenditure(as % of GDP) of Lebanon?
Give a very brief answer. 13.4. 